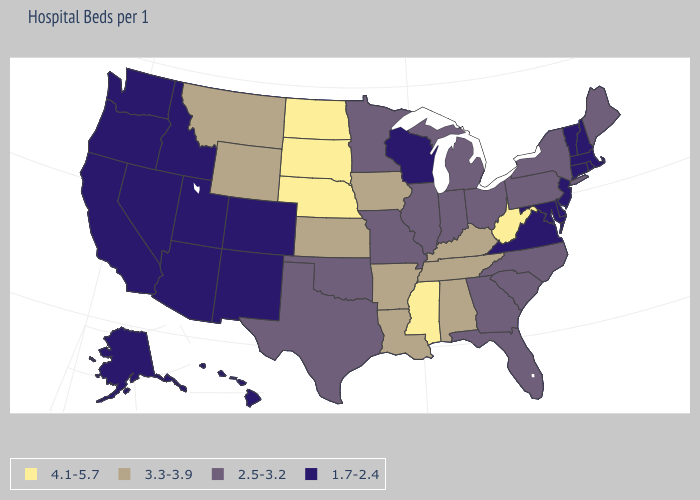What is the highest value in the South ?
Be succinct. 4.1-5.7. Name the states that have a value in the range 2.5-3.2?
Concise answer only. Florida, Georgia, Illinois, Indiana, Maine, Michigan, Minnesota, Missouri, New York, North Carolina, Ohio, Oklahoma, Pennsylvania, South Carolina, Texas. What is the value of New York?
Short answer required. 2.5-3.2. Is the legend a continuous bar?
Short answer required. No. Among the states that border Iowa , does Illinois have the highest value?
Answer briefly. No. Does Nevada have the lowest value in the West?
Answer briefly. Yes. Which states hav the highest value in the Northeast?
Concise answer only. Maine, New York, Pennsylvania. What is the value of North Dakota?
Be succinct. 4.1-5.7. How many symbols are there in the legend?
Be succinct. 4. Which states have the lowest value in the USA?
Keep it brief. Alaska, Arizona, California, Colorado, Connecticut, Delaware, Hawaii, Idaho, Maryland, Massachusetts, Nevada, New Hampshire, New Jersey, New Mexico, Oregon, Rhode Island, Utah, Vermont, Virginia, Washington, Wisconsin. Does Colorado have the lowest value in the USA?
Answer briefly. Yes. How many symbols are there in the legend?
Quick response, please. 4. Which states hav the highest value in the South?
Be succinct. Mississippi, West Virginia. What is the value of South Carolina?
Concise answer only. 2.5-3.2. 